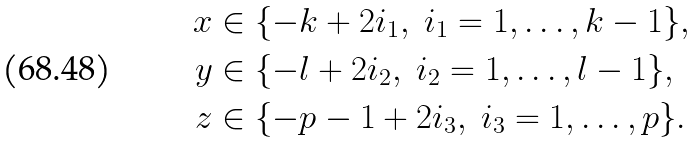Convert formula to latex. <formula><loc_0><loc_0><loc_500><loc_500>x & \in \{ - k + 2 i _ { 1 } , \ i _ { 1 } = 1 , \dots , k - 1 \} , \\ y & \in \{ - l + 2 i _ { 2 } , \ i _ { 2 } = 1 , \dots , l - 1 \} , \\ z & \in \{ - p - 1 + 2 i _ { 3 } , \ i _ { 3 } = 1 , \dots , p \} .</formula> 